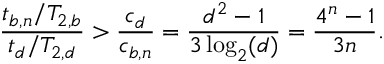Convert formula to latex. <formula><loc_0><loc_0><loc_500><loc_500>\frac { t _ { b , n } / T _ { 2 , b } } { t _ { d } / T _ { 2 , d } } > \frac { c _ { d } } { c _ { b , n } } = \frac { d ^ { 2 } - 1 } { 3 \log _ { 2 } ( d ) } = \frac { 4 ^ { n } - 1 } { 3 n } .</formula> 